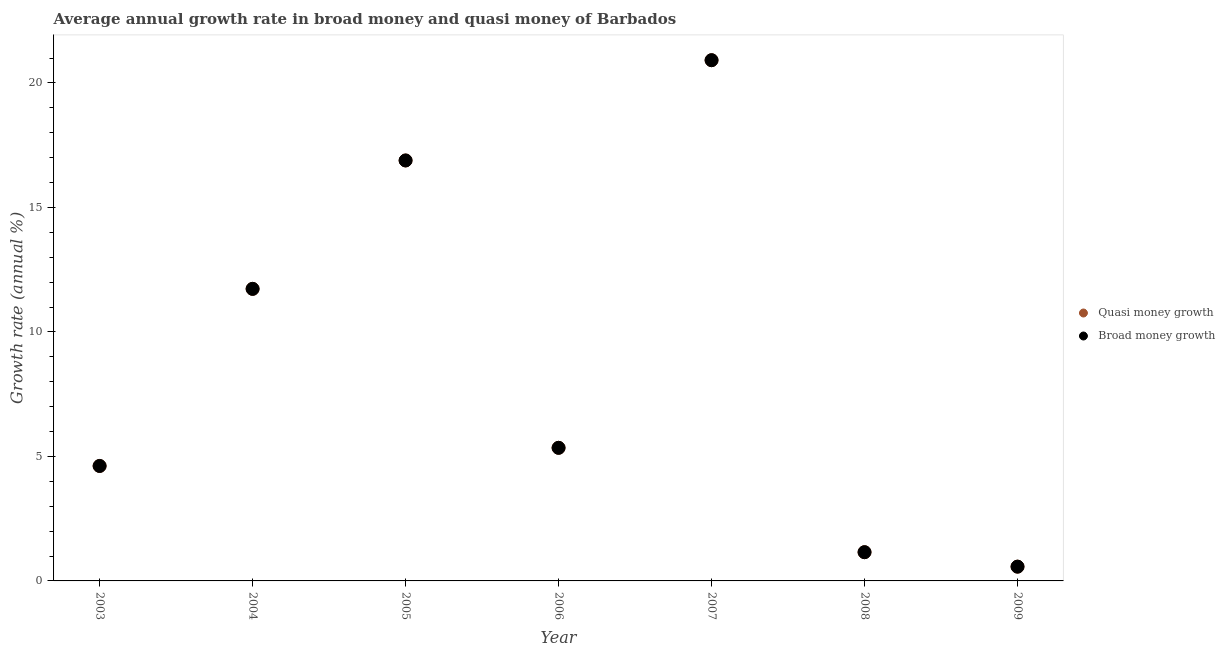How many different coloured dotlines are there?
Provide a succinct answer. 2. What is the annual growth rate in broad money in 2008?
Your answer should be compact. 1.15. Across all years, what is the maximum annual growth rate in quasi money?
Keep it short and to the point. 20.91. Across all years, what is the minimum annual growth rate in broad money?
Make the answer very short. 0.57. In which year was the annual growth rate in broad money maximum?
Your response must be concise. 2007. In which year was the annual growth rate in quasi money minimum?
Offer a terse response. 2009. What is the total annual growth rate in quasi money in the graph?
Make the answer very short. 61.22. What is the difference between the annual growth rate in quasi money in 2005 and that in 2007?
Provide a succinct answer. -4.03. What is the difference between the annual growth rate in broad money in 2006 and the annual growth rate in quasi money in 2005?
Your response must be concise. -11.54. What is the average annual growth rate in quasi money per year?
Offer a very short reply. 8.75. In how many years, is the annual growth rate in broad money greater than 8 %?
Give a very brief answer. 3. What is the ratio of the annual growth rate in quasi money in 2004 to that in 2009?
Provide a short and direct response. 20.47. Is the difference between the annual growth rate in broad money in 2004 and 2006 greater than the difference between the annual growth rate in quasi money in 2004 and 2006?
Your answer should be very brief. No. What is the difference between the highest and the second highest annual growth rate in quasi money?
Give a very brief answer. 4.03. What is the difference between the highest and the lowest annual growth rate in broad money?
Offer a very short reply. 20.34. Is the sum of the annual growth rate in quasi money in 2003 and 2004 greater than the maximum annual growth rate in broad money across all years?
Ensure brevity in your answer.  No. Does the annual growth rate in broad money monotonically increase over the years?
Your answer should be compact. No. Is the annual growth rate in broad money strictly greater than the annual growth rate in quasi money over the years?
Offer a very short reply. No. How many dotlines are there?
Your response must be concise. 2. How many years are there in the graph?
Keep it short and to the point. 7. Does the graph contain any zero values?
Make the answer very short. No. Does the graph contain grids?
Offer a terse response. No. What is the title of the graph?
Provide a short and direct response. Average annual growth rate in broad money and quasi money of Barbados. Does "Resident" appear as one of the legend labels in the graph?
Your answer should be compact. No. What is the label or title of the X-axis?
Provide a succinct answer. Year. What is the label or title of the Y-axis?
Provide a short and direct response. Growth rate (annual %). What is the Growth rate (annual %) of Quasi money growth in 2003?
Keep it short and to the point. 4.62. What is the Growth rate (annual %) of Broad money growth in 2003?
Keep it short and to the point. 4.62. What is the Growth rate (annual %) in Quasi money growth in 2004?
Ensure brevity in your answer.  11.73. What is the Growth rate (annual %) of Broad money growth in 2004?
Offer a very short reply. 11.73. What is the Growth rate (annual %) of Quasi money growth in 2005?
Give a very brief answer. 16.89. What is the Growth rate (annual %) in Broad money growth in 2005?
Make the answer very short. 16.89. What is the Growth rate (annual %) in Quasi money growth in 2006?
Keep it short and to the point. 5.35. What is the Growth rate (annual %) of Broad money growth in 2006?
Offer a terse response. 5.35. What is the Growth rate (annual %) of Quasi money growth in 2007?
Your answer should be very brief. 20.91. What is the Growth rate (annual %) of Broad money growth in 2007?
Provide a short and direct response. 20.91. What is the Growth rate (annual %) of Quasi money growth in 2008?
Give a very brief answer. 1.15. What is the Growth rate (annual %) of Broad money growth in 2008?
Provide a succinct answer. 1.15. What is the Growth rate (annual %) in Quasi money growth in 2009?
Offer a very short reply. 0.57. What is the Growth rate (annual %) of Broad money growth in 2009?
Offer a very short reply. 0.57. Across all years, what is the maximum Growth rate (annual %) in Quasi money growth?
Offer a very short reply. 20.91. Across all years, what is the maximum Growth rate (annual %) in Broad money growth?
Offer a very short reply. 20.91. Across all years, what is the minimum Growth rate (annual %) of Quasi money growth?
Your response must be concise. 0.57. Across all years, what is the minimum Growth rate (annual %) in Broad money growth?
Provide a succinct answer. 0.57. What is the total Growth rate (annual %) in Quasi money growth in the graph?
Offer a terse response. 61.22. What is the total Growth rate (annual %) of Broad money growth in the graph?
Give a very brief answer. 61.22. What is the difference between the Growth rate (annual %) of Quasi money growth in 2003 and that in 2004?
Provide a short and direct response. -7.11. What is the difference between the Growth rate (annual %) in Broad money growth in 2003 and that in 2004?
Your answer should be very brief. -7.11. What is the difference between the Growth rate (annual %) in Quasi money growth in 2003 and that in 2005?
Your answer should be very brief. -12.27. What is the difference between the Growth rate (annual %) of Broad money growth in 2003 and that in 2005?
Provide a short and direct response. -12.27. What is the difference between the Growth rate (annual %) in Quasi money growth in 2003 and that in 2006?
Give a very brief answer. -0.73. What is the difference between the Growth rate (annual %) in Broad money growth in 2003 and that in 2006?
Give a very brief answer. -0.73. What is the difference between the Growth rate (annual %) of Quasi money growth in 2003 and that in 2007?
Provide a short and direct response. -16.3. What is the difference between the Growth rate (annual %) of Broad money growth in 2003 and that in 2007?
Your response must be concise. -16.3. What is the difference between the Growth rate (annual %) in Quasi money growth in 2003 and that in 2008?
Offer a very short reply. 3.46. What is the difference between the Growth rate (annual %) of Broad money growth in 2003 and that in 2008?
Provide a short and direct response. 3.46. What is the difference between the Growth rate (annual %) in Quasi money growth in 2003 and that in 2009?
Ensure brevity in your answer.  4.04. What is the difference between the Growth rate (annual %) in Broad money growth in 2003 and that in 2009?
Give a very brief answer. 4.04. What is the difference between the Growth rate (annual %) of Quasi money growth in 2004 and that in 2005?
Your response must be concise. -5.16. What is the difference between the Growth rate (annual %) in Broad money growth in 2004 and that in 2005?
Offer a terse response. -5.16. What is the difference between the Growth rate (annual %) in Quasi money growth in 2004 and that in 2006?
Keep it short and to the point. 6.38. What is the difference between the Growth rate (annual %) of Broad money growth in 2004 and that in 2006?
Your answer should be very brief. 6.38. What is the difference between the Growth rate (annual %) in Quasi money growth in 2004 and that in 2007?
Give a very brief answer. -9.18. What is the difference between the Growth rate (annual %) in Broad money growth in 2004 and that in 2007?
Your response must be concise. -9.18. What is the difference between the Growth rate (annual %) of Quasi money growth in 2004 and that in 2008?
Your response must be concise. 10.58. What is the difference between the Growth rate (annual %) of Broad money growth in 2004 and that in 2008?
Your answer should be very brief. 10.58. What is the difference between the Growth rate (annual %) in Quasi money growth in 2004 and that in 2009?
Your answer should be compact. 11.16. What is the difference between the Growth rate (annual %) in Broad money growth in 2004 and that in 2009?
Offer a very short reply. 11.16. What is the difference between the Growth rate (annual %) in Quasi money growth in 2005 and that in 2006?
Offer a very short reply. 11.54. What is the difference between the Growth rate (annual %) in Broad money growth in 2005 and that in 2006?
Your response must be concise. 11.54. What is the difference between the Growth rate (annual %) of Quasi money growth in 2005 and that in 2007?
Your response must be concise. -4.03. What is the difference between the Growth rate (annual %) of Broad money growth in 2005 and that in 2007?
Your answer should be very brief. -4.03. What is the difference between the Growth rate (annual %) in Quasi money growth in 2005 and that in 2008?
Make the answer very short. 15.73. What is the difference between the Growth rate (annual %) of Broad money growth in 2005 and that in 2008?
Your answer should be very brief. 15.73. What is the difference between the Growth rate (annual %) of Quasi money growth in 2005 and that in 2009?
Give a very brief answer. 16.31. What is the difference between the Growth rate (annual %) in Broad money growth in 2005 and that in 2009?
Offer a terse response. 16.31. What is the difference between the Growth rate (annual %) in Quasi money growth in 2006 and that in 2007?
Make the answer very short. -15.57. What is the difference between the Growth rate (annual %) of Broad money growth in 2006 and that in 2007?
Your response must be concise. -15.57. What is the difference between the Growth rate (annual %) of Quasi money growth in 2006 and that in 2008?
Your response must be concise. 4.19. What is the difference between the Growth rate (annual %) in Broad money growth in 2006 and that in 2008?
Offer a terse response. 4.19. What is the difference between the Growth rate (annual %) in Quasi money growth in 2006 and that in 2009?
Ensure brevity in your answer.  4.77. What is the difference between the Growth rate (annual %) in Broad money growth in 2006 and that in 2009?
Give a very brief answer. 4.77. What is the difference between the Growth rate (annual %) in Quasi money growth in 2007 and that in 2008?
Provide a short and direct response. 19.76. What is the difference between the Growth rate (annual %) in Broad money growth in 2007 and that in 2008?
Provide a short and direct response. 19.76. What is the difference between the Growth rate (annual %) of Quasi money growth in 2007 and that in 2009?
Your answer should be compact. 20.34. What is the difference between the Growth rate (annual %) in Broad money growth in 2007 and that in 2009?
Offer a terse response. 20.34. What is the difference between the Growth rate (annual %) in Quasi money growth in 2008 and that in 2009?
Your response must be concise. 0.58. What is the difference between the Growth rate (annual %) in Broad money growth in 2008 and that in 2009?
Your answer should be very brief. 0.58. What is the difference between the Growth rate (annual %) of Quasi money growth in 2003 and the Growth rate (annual %) of Broad money growth in 2004?
Offer a terse response. -7.11. What is the difference between the Growth rate (annual %) of Quasi money growth in 2003 and the Growth rate (annual %) of Broad money growth in 2005?
Offer a terse response. -12.27. What is the difference between the Growth rate (annual %) of Quasi money growth in 2003 and the Growth rate (annual %) of Broad money growth in 2006?
Offer a terse response. -0.73. What is the difference between the Growth rate (annual %) in Quasi money growth in 2003 and the Growth rate (annual %) in Broad money growth in 2007?
Offer a very short reply. -16.3. What is the difference between the Growth rate (annual %) of Quasi money growth in 2003 and the Growth rate (annual %) of Broad money growth in 2008?
Your answer should be compact. 3.46. What is the difference between the Growth rate (annual %) in Quasi money growth in 2003 and the Growth rate (annual %) in Broad money growth in 2009?
Your response must be concise. 4.04. What is the difference between the Growth rate (annual %) of Quasi money growth in 2004 and the Growth rate (annual %) of Broad money growth in 2005?
Provide a succinct answer. -5.16. What is the difference between the Growth rate (annual %) in Quasi money growth in 2004 and the Growth rate (annual %) in Broad money growth in 2006?
Make the answer very short. 6.38. What is the difference between the Growth rate (annual %) in Quasi money growth in 2004 and the Growth rate (annual %) in Broad money growth in 2007?
Give a very brief answer. -9.18. What is the difference between the Growth rate (annual %) in Quasi money growth in 2004 and the Growth rate (annual %) in Broad money growth in 2008?
Provide a succinct answer. 10.58. What is the difference between the Growth rate (annual %) of Quasi money growth in 2004 and the Growth rate (annual %) of Broad money growth in 2009?
Your response must be concise. 11.16. What is the difference between the Growth rate (annual %) of Quasi money growth in 2005 and the Growth rate (annual %) of Broad money growth in 2006?
Your answer should be very brief. 11.54. What is the difference between the Growth rate (annual %) of Quasi money growth in 2005 and the Growth rate (annual %) of Broad money growth in 2007?
Keep it short and to the point. -4.03. What is the difference between the Growth rate (annual %) in Quasi money growth in 2005 and the Growth rate (annual %) in Broad money growth in 2008?
Make the answer very short. 15.73. What is the difference between the Growth rate (annual %) in Quasi money growth in 2005 and the Growth rate (annual %) in Broad money growth in 2009?
Give a very brief answer. 16.31. What is the difference between the Growth rate (annual %) in Quasi money growth in 2006 and the Growth rate (annual %) in Broad money growth in 2007?
Provide a succinct answer. -15.57. What is the difference between the Growth rate (annual %) of Quasi money growth in 2006 and the Growth rate (annual %) of Broad money growth in 2008?
Your answer should be compact. 4.19. What is the difference between the Growth rate (annual %) of Quasi money growth in 2006 and the Growth rate (annual %) of Broad money growth in 2009?
Give a very brief answer. 4.77. What is the difference between the Growth rate (annual %) of Quasi money growth in 2007 and the Growth rate (annual %) of Broad money growth in 2008?
Provide a short and direct response. 19.76. What is the difference between the Growth rate (annual %) in Quasi money growth in 2007 and the Growth rate (annual %) in Broad money growth in 2009?
Make the answer very short. 20.34. What is the difference between the Growth rate (annual %) in Quasi money growth in 2008 and the Growth rate (annual %) in Broad money growth in 2009?
Ensure brevity in your answer.  0.58. What is the average Growth rate (annual %) in Quasi money growth per year?
Keep it short and to the point. 8.75. What is the average Growth rate (annual %) of Broad money growth per year?
Provide a short and direct response. 8.75. In the year 2005, what is the difference between the Growth rate (annual %) in Quasi money growth and Growth rate (annual %) in Broad money growth?
Give a very brief answer. 0. In the year 2007, what is the difference between the Growth rate (annual %) of Quasi money growth and Growth rate (annual %) of Broad money growth?
Make the answer very short. 0. In the year 2009, what is the difference between the Growth rate (annual %) of Quasi money growth and Growth rate (annual %) of Broad money growth?
Keep it short and to the point. 0. What is the ratio of the Growth rate (annual %) in Quasi money growth in 2003 to that in 2004?
Provide a short and direct response. 0.39. What is the ratio of the Growth rate (annual %) in Broad money growth in 2003 to that in 2004?
Keep it short and to the point. 0.39. What is the ratio of the Growth rate (annual %) in Quasi money growth in 2003 to that in 2005?
Provide a short and direct response. 0.27. What is the ratio of the Growth rate (annual %) in Broad money growth in 2003 to that in 2005?
Your response must be concise. 0.27. What is the ratio of the Growth rate (annual %) in Quasi money growth in 2003 to that in 2006?
Your response must be concise. 0.86. What is the ratio of the Growth rate (annual %) in Broad money growth in 2003 to that in 2006?
Your response must be concise. 0.86. What is the ratio of the Growth rate (annual %) of Quasi money growth in 2003 to that in 2007?
Your answer should be very brief. 0.22. What is the ratio of the Growth rate (annual %) of Broad money growth in 2003 to that in 2007?
Your response must be concise. 0.22. What is the ratio of the Growth rate (annual %) of Quasi money growth in 2003 to that in 2008?
Offer a terse response. 4. What is the ratio of the Growth rate (annual %) of Broad money growth in 2003 to that in 2008?
Your response must be concise. 4. What is the ratio of the Growth rate (annual %) of Quasi money growth in 2003 to that in 2009?
Provide a short and direct response. 8.06. What is the ratio of the Growth rate (annual %) in Broad money growth in 2003 to that in 2009?
Offer a terse response. 8.06. What is the ratio of the Growth rate (annual %) in Quasi money growth in 2004 to that in 2005?
Your response must be concise. 0.69. What is the ratio of the Growth rate (annual %) in Broad money growth in 2004 to that in 2005?
Give a very brief answer. 0.69. What is the ratio of the Growth rate (annual %) in Quasi money growth in 2004 to that in 2006?
Your answer should be compact. 2.19. What is the ratio of the Growth rate (annual %) in Broad money growth in 2004 to that in 2006?
Make the answer very short. 2.19. What is the ratio of the Growth rate (annual %) in Quasi money growth in 2004 to that in 2007?
Your answer should be compact. 0.56. What is the ratio of the Growth rate (annual %) in Broad money growth in 2004 to that in 2007?
Offer a terse response. 0.56. What is the ratio of the Growth rate (annual %) of Quasi money growth in 2004 to that in 2008?
Offer a terse response. 10.16. What is the ratio of the Growth rate (annual %) of Broad money growth in 2004 to that in 2008?
Make the answer very short. 10.16. What is the ratio of the Growth rate (annual %) in Quasi money growth in 2004 to that in 2009?
Your response must be concise. 20.47. What is the ratio of the Growth rate (annual %) of Broad money growth in 2004 to that in 2009?
Offer a terse response. 20.47. What is the ratio of the Growth rate (annual %) in Quasi money growth in 2005 to that in 2006?
Your answer should be very brief. 3.16. What is the ratio of the Growth rate (annual %) in Broad money growth in 2005 to that in 2006?
Your response must be concise. 3.16. What is the ratio of the Growth rate (annual %) of Quasi money growth in 2005 to that in 2007?
Your response must be concise. 0.81. What is the ratio of the Growth rate (annual %) in Broad money growth in 2005 to that in 2007?
Make the answer very short. 0.81. What is the ratio of the Growth rate (annual %) of Quasi money growth in 2005 to that in 2008?
Your answer should be very brief. 14.63. What is the ratio of the Growth rate (annual %) of Broad money growth in 2005 to that in 2008?
Your response must be concise. 14.63. What is the ratio of the Growth rate (annual %) in Quasi money growth in 2005 to that in 2009?
Your answer should be compact. 29.47. What is the ratio of the Growth rate (annual %) of Broad money growth in 2005 to that in 2009?
Provide a succinct answer. 29.47. What is the ratio of the Growth rate (annual %) in Quasi money growth in 2006 to that in 2007?
Keep it short and to the point. 0.26. What is the ratio of the Growth rate (annual %) of Broad money growth in 2006 to that in 2007?
Make the answer very short. 0.26. What is the ratio of the Growth rate (annual %) in Quasi money growth in 2006 to that in 2008?
Ensure brevity in your answer.  4.63. What is the ratio of the Growth rate (annual %) of Broad money growth in 2006 to that in 2008?
Ensure brevity in your answer.  4.63. What is the ratio of the Growth rate (annual %) in Quasi money growth in 2006 to that in 2009?
Keep it short and to the point. 9.33. What is the ratio of the Growth rate (annual %) of Broad money growth in 2006 to that in 2009?
Keep it short and to the point. 9.33. What is the ratio of the Growth rate (annual %) of Quasi money growth in 2007 to that in 2008?
Make the answer very short. 18.12. What is the ratio of the Growth rate (annual %) in Broad money growth in 2007 to that in 2008?
Offer a very short reply. 18.12. What is the ratio of the Growth rate (annual %) in Quasi money growth in 2007 to that in 2009?
Offer a very short reply. 36.49. What is the ratio of the Growth rate (annual %) in Broad money growth in 2007 to that in 2009?
Your answer should be very brief. 36.49. What is the ratio of the Growth rate (annual %) in Quasi money growth in 2008 to that in 2009?
Your answer should be very brief. 2.01. What is the ratio of the Growth rate (annual %) in Broad money growth in 2008 to that in 2009?
Provide a succinct answer. 2.01. What is the difference between the highest and the second highest Growth rate (annual %) of Quasi money growth?
Make the answer very short. 4.03. What is the difference between the highest and the second highest Growth rate (annual %) in Broad money growth?
Provide a succinct answer. 4.03. What is the difference between the highest and the lowest Growth rate (annual %) of Quasi money growth?
Your response must be concise. 20.34. What is the difference between the highest and the lowest Growth rate (annual %) of Broad money growth?
Your answer should be very brief. 20.34. 